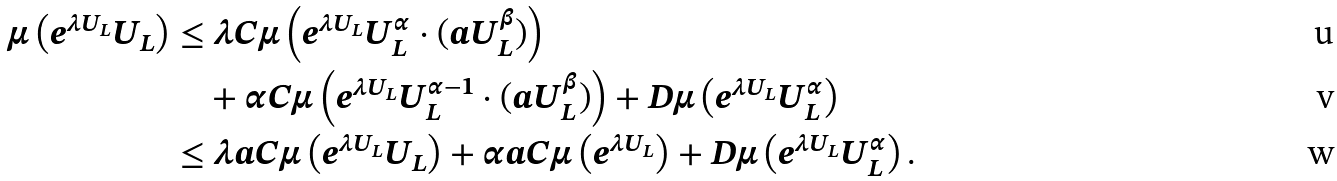Convert formula to latex. <formula><loc_0><loc_0><loc_500><loc_500>\mu \left ( e ^ { \lambda U _ { L } } U _ { L } \right ) & \leq \lambda C \mu \left ( e ^ { \lambda U _ { L } } U _ { L } ^ { \alpha } \cdot ( a U _ { L } ^ { \beta } ) \right ) \\ & \quad + \alpha C \mu \left ( e ^ { \lambda U _ { L } } U _ { L } ^ { \alpha - 1 } \cdot ( a U _ { L } ^ { \beta } ) \right ) + D \mu \left ( e ^ { \lambda U _ { L } } U _ { L } ^ { \alpha } \right ) \\ & \leq \lambda a C \mu \left ( e ^ { \lambda U _ { L } } U _ { L } \right ) + \alpha a C \mu \left ( e ^ { \lambda U _ { L } } \right ) + D \mu \left ( e ^ { \lambda U _ { L } } U _ { L } ^ { \alpha } \right ) .</formula> 